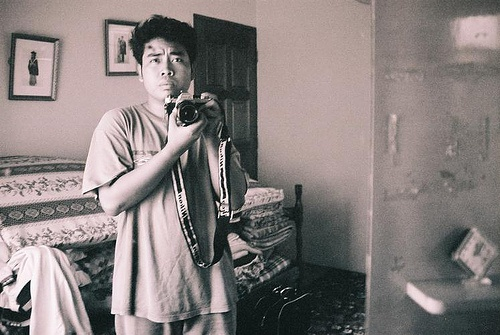Describe the objects in this image and their specific colors. I can see people in gray, lightgray, black, and darkgray tones, bed in gray, lightgray, darkgray, and black tones, suitcase in gray, black, darkgray, and purple tones, and clock in gray and darkgray tones in this image. 